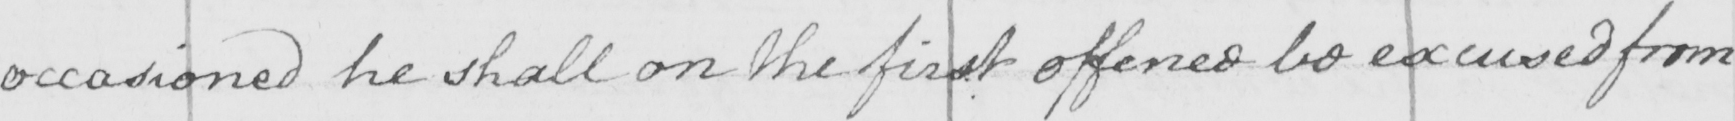Can you read and transcribe this handwriting? occasioned he shall on the first offence be excused from 